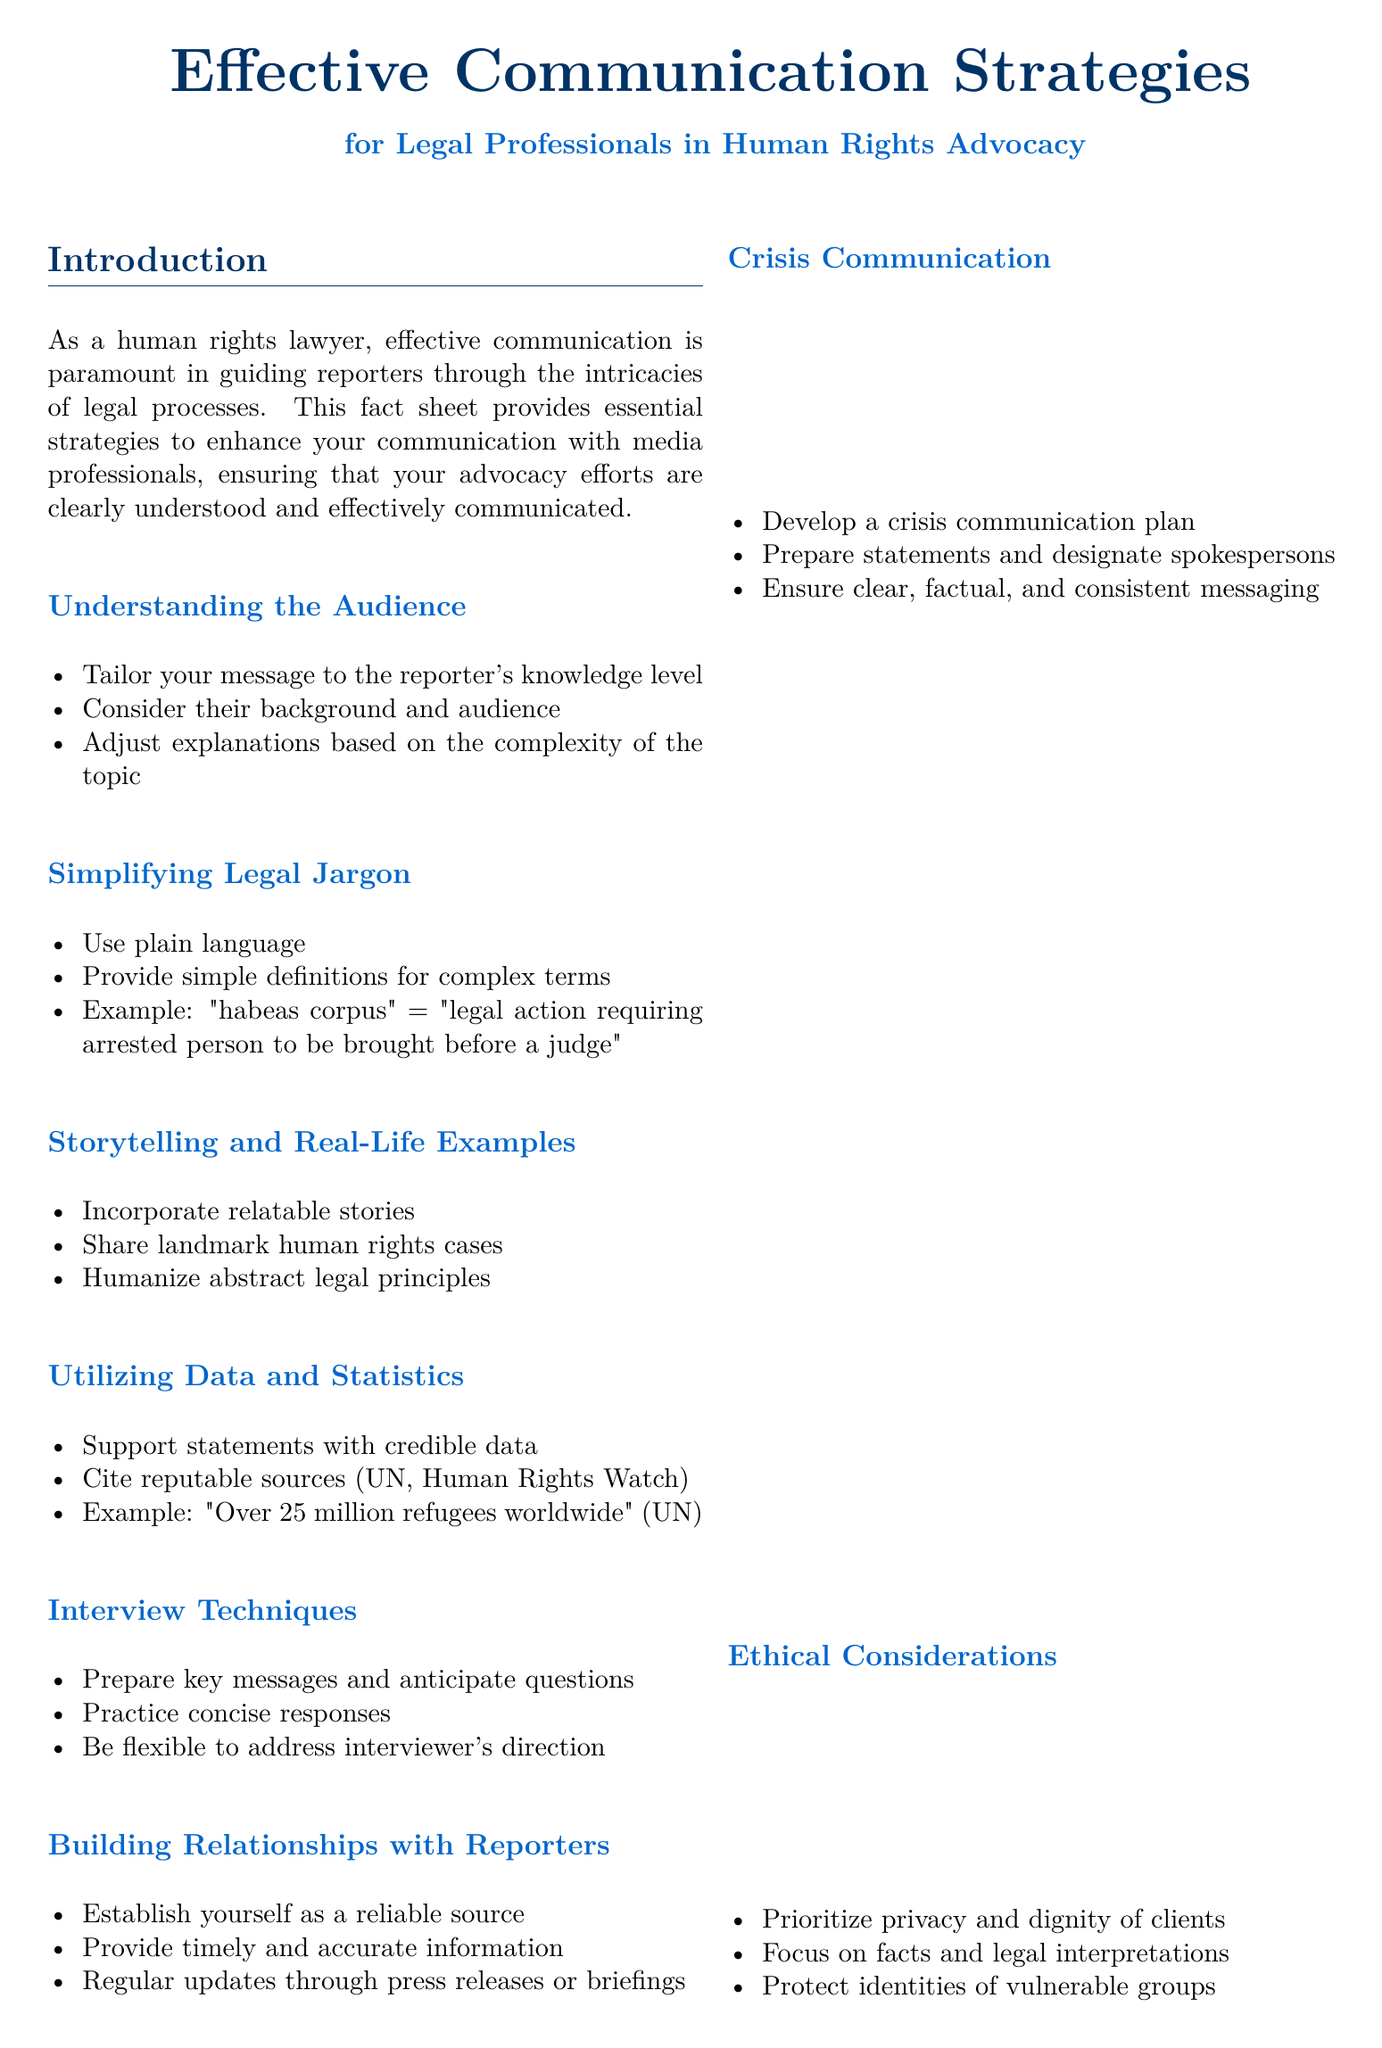What is the title of the fact sheet? The title of the fact sheet is prominently displayed at the top of the document and summarizes the main topic it addresses.
Answer: Effective Communication Strategies for Legal Professionals in Human Rights Advocacy What is one strategy for understanding the audience? The document lists strategies under the section "Understanding the Audience," which includes tailoring messages to fit the audience's needs.
Answer: Tailor your message to the reporter's knowledge level What is an example of simplifying legal jargon? The section on simplifying legal jargon provides a specific example to illustrate how complex terms can be explained in simpler language.
Answer: "habeas corpus" = "legal action requiring arrested person to be brought before a judge" Which organization is mentioned as a resource for legal professionals? The document lists several resources at the end, providing names of organizations that support legal advocacy.
Answer: International Bar Association What is a key element of crisis communication mentioned in the fact sheet? The section on crisis communication outlines important components that should be included in a crisis plan.
Answer: Develop a crisis communication plan How should ethical considerations be prioritized according to the document? The ethical considerations section stresses important principles that legal professionals should uphold while communicating.
Answer: Prioritize privacy and dignity of clients What is suggested for building relationships with reporters? Strategies for establishing rapport with reporters are detailed, urging actions that build trust and reliability.
Answer: Establish yourself as a reliable source What type of data should be utilized to support statements? The segment on utilizing data and statistics emphasizes the importance of credible data sources in communication.
Answer: Cite reputable sources (UN, Human Rights Watch) How should summaries be prepared for interviews? In the interview techniques section, it specifies how lawyers should prepare for the interview process effectively.
Answer: Prepare key messages and anticipate questions 